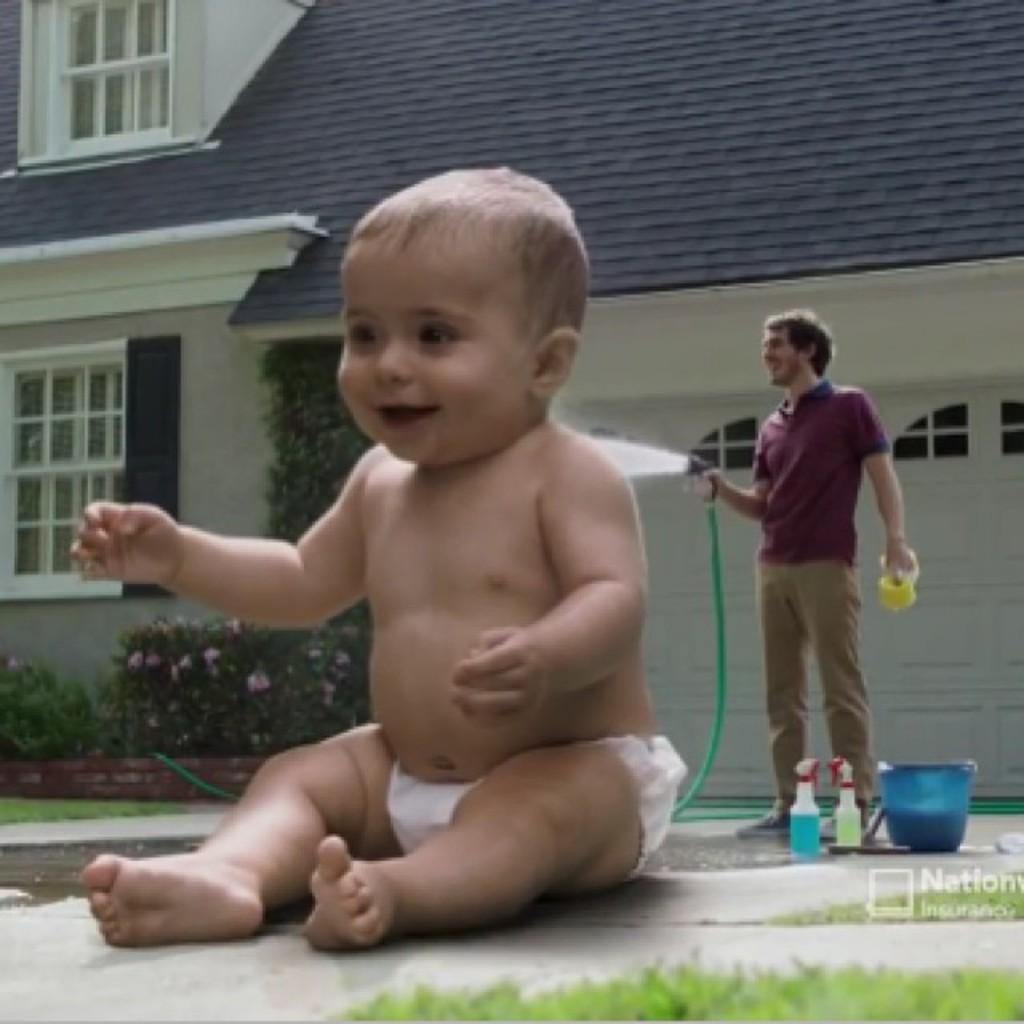In one or two sentences, can you explain what this image depicts? In this picture we can see a small baby sitting in the front and smiling. Behind we can see the man with water pipe. In the background there is a building with grey color roof tiles. 